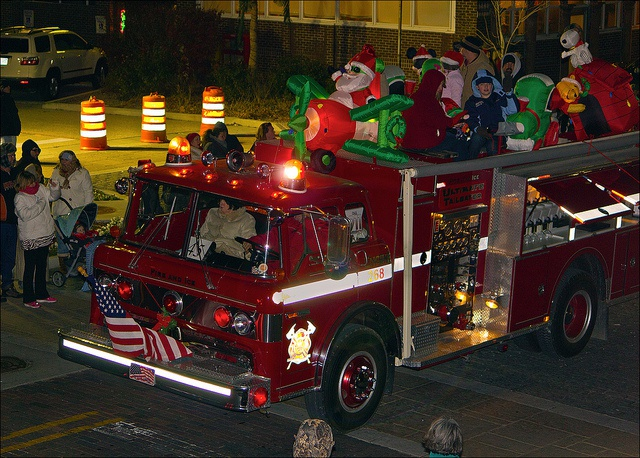Describe the objects in this image and their specific colors. I can see truck in black, maroon, and gray tones, people in black, maroon, gray, and orange tones, car in black and olive tones, people in black, maroon, and gray tones, and people in black, gray, and maroon tones in this image. 